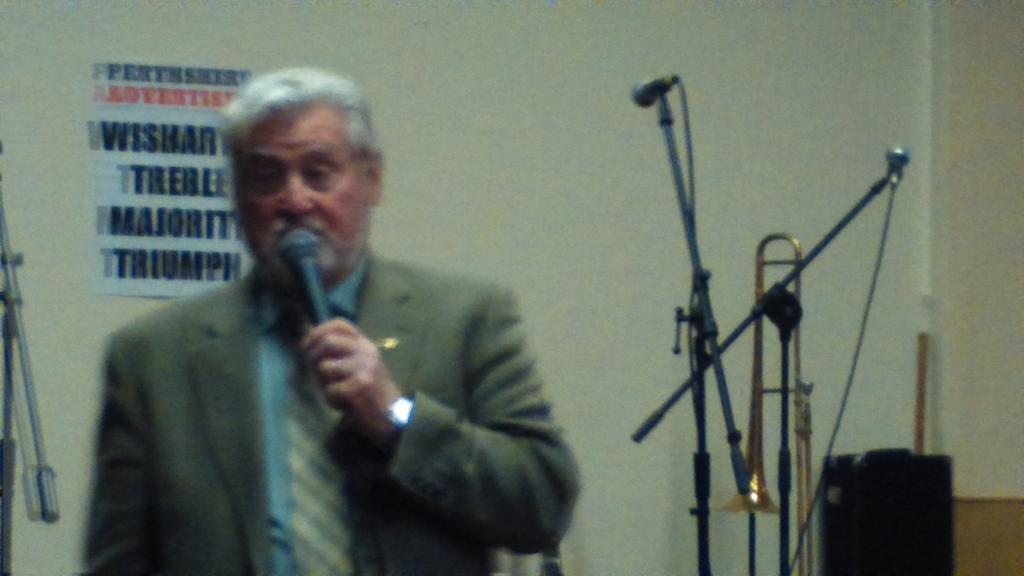Describe this image in one or two sentences. In this image there is a man standing and talking in a microphone, at the background there are microphones, trombones , wall, wall poster , speaker. 